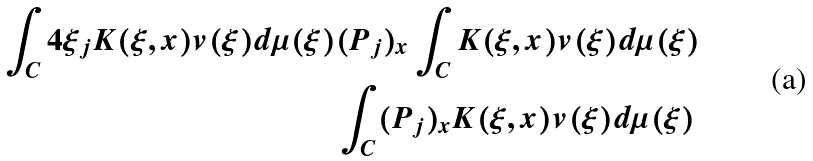Convert formula to latex. <formula><loc_0><loc_0><loc_500><loc_500>\int _ { C } 4 \xi _ { j } K ( \xi , x ) v ( \xi ) d \mu ( \xi ) & ( P _ { j } ) _ { x } \int _ { C } K ( \xi , x ) v ( \xi ) d \mu ( \xi ) \\ & \int _ { C } ( P _ { j } ) _ { x } K ( \xi , x ) v ( \xi ) d \mu ( \xi )</formula> 